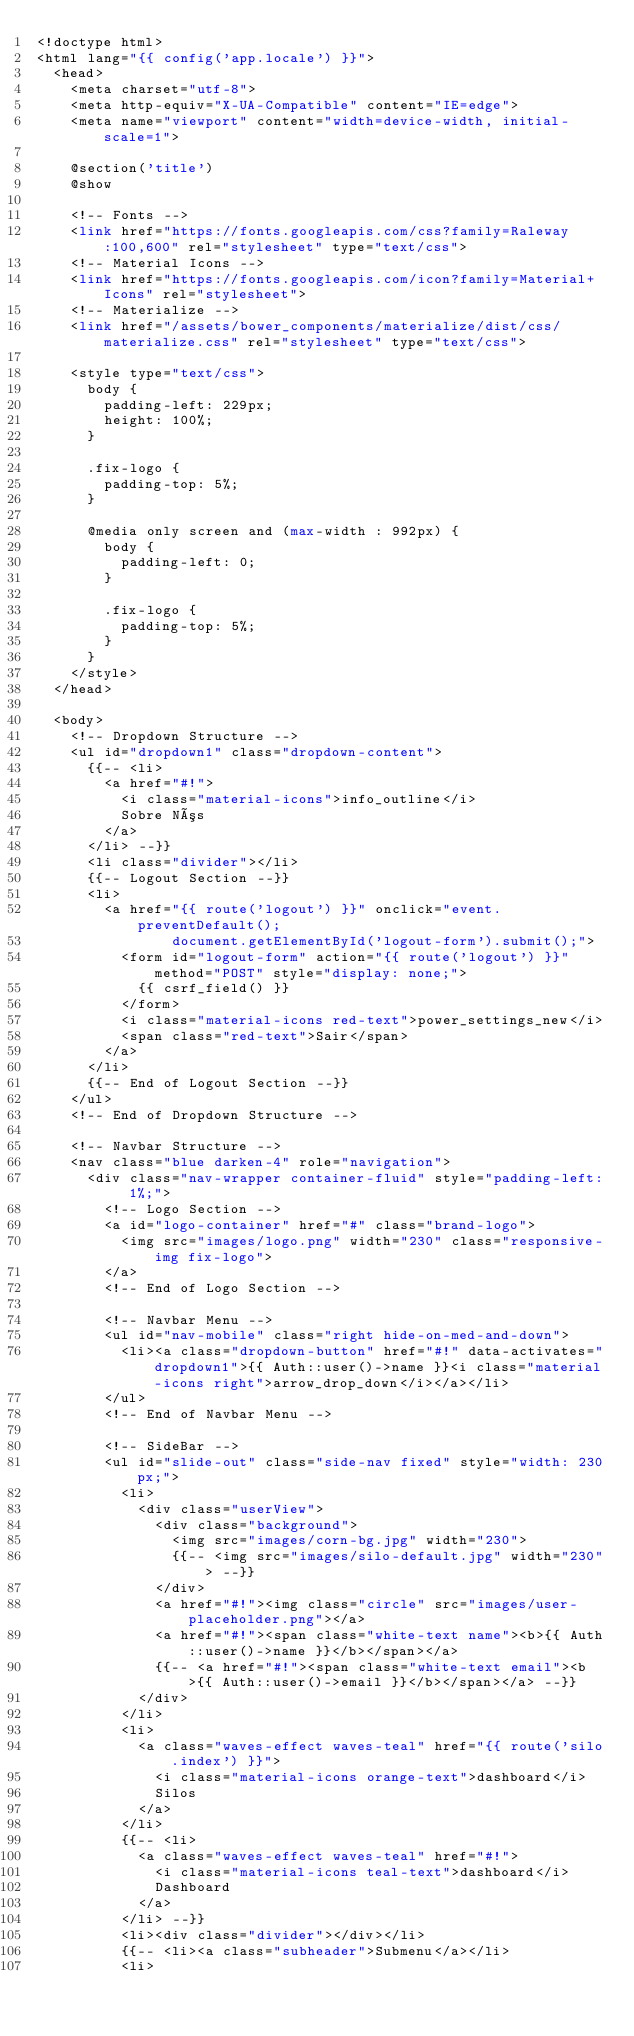<code> <loc_0><loc_0><loc_500><loc_500><_PHP_><!doctype html>
<html lang="{{ config('app.locale') }}">
  <head>
    <meta charset="utf-8">
    <meta http-equiv="X-UA-Compatible" content="IE=edge">
    <meta name="viewport" content="width=device-width, initial-scale=1">
        
    @section('title')
    @show

    <!-- Fonts -->
    <link href="https://fonts.googleapis.com/css?family=Raleway:100,600" rel="stylesheet" type="text/css">
    <!-- Material Icons -->
    <link href="https://fonts.googleapis.com/icon?family=Material+Icons" rel="stylesheet">
    <!-- Materialize -->
    <link href="/assets/bower_components/materialize/dist/css/materialize.css" rel="stylesheet" type="text/css">

    <style type="text/css">
      body {
        padding-left: 229px;
        height: 100%;
      }

      .fix-logo {
        padding-top: 5%;
      }

      @media only screen and (max-width : 992px) {
        body {
          padding-left: 0;
        }

        .fix-logo {
          padding-top: 5%;
        }
      }
    </style>
  </head>

  <body>
    <!-- Dropdown Structure -->
    <ul id="dropdown1" class="dropdown-content">
      {{-- <li>
        <a href="#!">
          <i class="material-icons">info_outline</i>
          Sobre Nós
        </a>
      </li> --}}
      <li class="divider"></li>
      {{-- Logout Section --}}
      <li>
        <a href="{{ route('logout') }}" onclick="event.preventDefault();
                document.getElementById('logout-form').submit();">
          <form id="logout-form" action="{{ route('logout') }}" method="POST" style="display: none;">
            {{ csrf_field() }}
          </form>
          <i class="material-icons red-text">power_settings_new</i>
          <span class="red-text">Sair</span>
        </a>
      </li>
      {{-- End of Logout Section --}}
    </ul>
    <!-- End of Dropdown Structure -->

    <!-- Navbar Structure -->
    <nav class="blue darken-4" role="navigation">
      <div class="nav-wrapper container-fluid" style="padding-left: 1%;">
        <!-- Logo Section -->
        <a id="logo-container" href="#" class="brand-logo">
          <img src="images/logo.png" width="230" class="responsive-img fix-logo"> 
        </a>
        <!-- End of Logo Section -->
        
        <!-- Navbar Menu -->
        <ul id="nav-mobile" class="right hide-on-med-and-down">
          <li><a class="dropdown-button" href="#!" data-activates="dropdown1">{{ Auth::user()->name }}<i class="material-icons right">arrow_drop_down</i></a></li>
        </ul>
        <!-- End of Navbar Menu -->

        <!-- SideBar -->
        <ul id="slide-out" class="side-nav fixed" style="width: 230px;">
          <li>
            <div class="userView">
              <div class="background">
                <img src="images/corn-bg.jpg" width="230">
                {{-- <img src="images/silo-default.jpg" width="230"> --}}
              </div>
              <a href="#!"><img class="circle" src="images/user-placeholder.png"></a>
              <a href="#!"><span class="white-text name"><b>{{ Auth::user()->name }}</b></span></a>
              {{-- <a href="#!"><span class="white-text email"><b>{{ Auth::user()->email }}</b></span></a> --}}
            </div>
          </li>
          <li>
            <a class="waves-effect waves-teal" href="{{ route('silo.index') }}">
              <i class="material-icons orange-text">dashboard</i>
              Silos
            </a>
          </li>
          {{-- <li>
            <a class="waves-effect waves-teal" href="#!">
              <i class="material-icons teal-text">dashboard</i>
              Dashboard
            </a>
          </li> --}}
          <li><div class="divider"></div></li>
          {{-- <li><a class="subheader">Submenu</a></li>
          <li></code> 